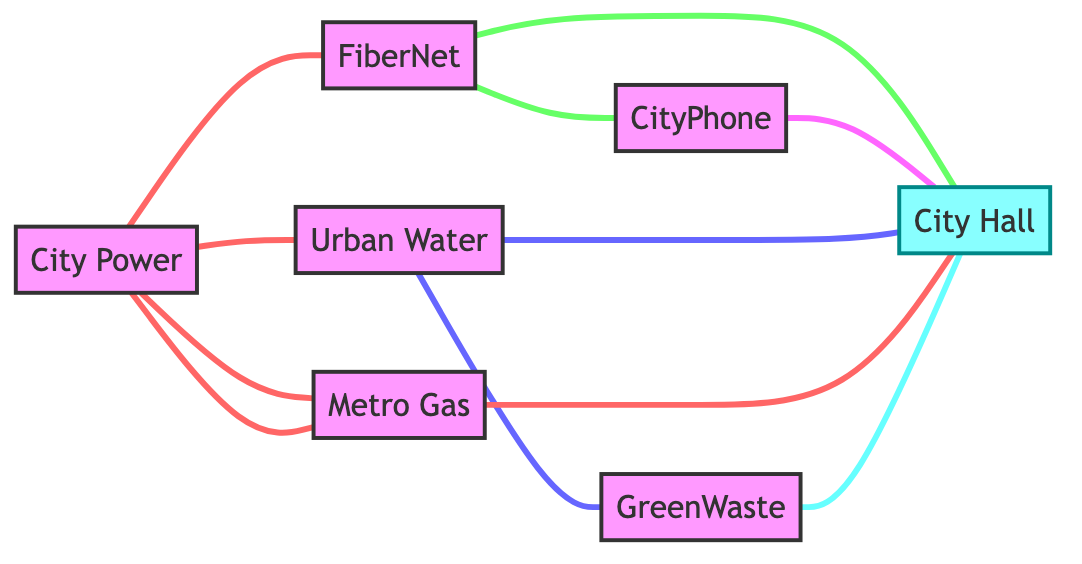What is the total number of utility providers in the diagram? The diagram lists six distinct utility providers: City Power, Urban Water, Metro Gas, FiberNet, GreenWaste, and CityPhone, making a total of six.
Answer: 6 Which provider supplies electricity to FiberNet? The diagram indicates that City Power is connected to FiberNet, indicating that City Power supplies electricity to FiberNet's data centers.
Answer: City Power What is the relationship between Urban Water and GreenWaste? The diagram shows a direct connection between Urban Water and GreenWaste, labeled as "WaterSupply," which describes how Urban Water supports GreenWaste's cleaning operations.
Answer: WaterSupply How many relationships does Urban Water have in total? Urban Water is connected by relationships to three different entities: City Power, GreenWaste, and City Hall, indicating three total relationships involving Urban Water.
Answer: 3 What type of support does FiberNet provide to City Hall? The relationship labeled as "ServiceSupport" identifies that FiberNet offers internet services to City Hall, highlighting its support role.
Answer: ServiceSupport Which two entities have a mutual energy relationship? The diagram shows a bidirectional connection where Metro Gas and City Power are connected via "EnergyExchange", indicating they share energy supply and support.
Answer: Metro Gas and City Power Which provider ensures telecommunications for City Hall? According to the diagram, CityPhone is connected to City Hall with the relationship "CommunicationSupport," making it the provider responsible for telecommunications.
Answer: CityPhone How many edges connect to the Local Government? In the diagram, City Hall is connected to five distinct entities: Urban Water, Metro Gas, GreenWaste, FiberNet, and CityPhone, indicating there are five edges connecting to Local Government.
Answer: 5 Which utility provider has no direct connection to GreenWaste? The diagram illustrates that FiberNet does not have a direct connection to GreenWaste, indicating it is the utility provider not connected to GreenWaste.
Answer: FiberNet 